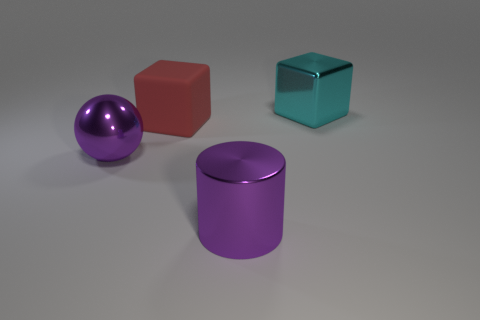Add 4 large cyan shiny spheres. How many objects exist? 8 Subtract all cyan cubes. How many cubes are left? 1 Add 3 big cylinders. How many big cylinders are left? 4 Add 2 yellow shiny things. How many yellow shiny things exist? 2 Subtract 0 green balls. How many objects are left? 4 Subtract all spheres. How many objects are left? 3 Subtract all gray cylinders. Subtract all red spheres. How many cylinders are left? 1 Subtract all green cylinders. How many red blocks are left? 1 Subtract all big purple things. Subtract all large metal cylinders. How many objects are left? 1 